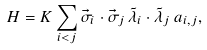Convert formula to latex. <formula><loc_0><loc_0><loc_500><loc_500>H = K \sum _ { i < j } \vec { \sigma } _ { i } \cdot \vec { \sigma } _ { j } \, \tilde { \lambda } _ { i } \cdot \tilde { \lambda } _ { j } \, a _ { i , j } ,</formula> 